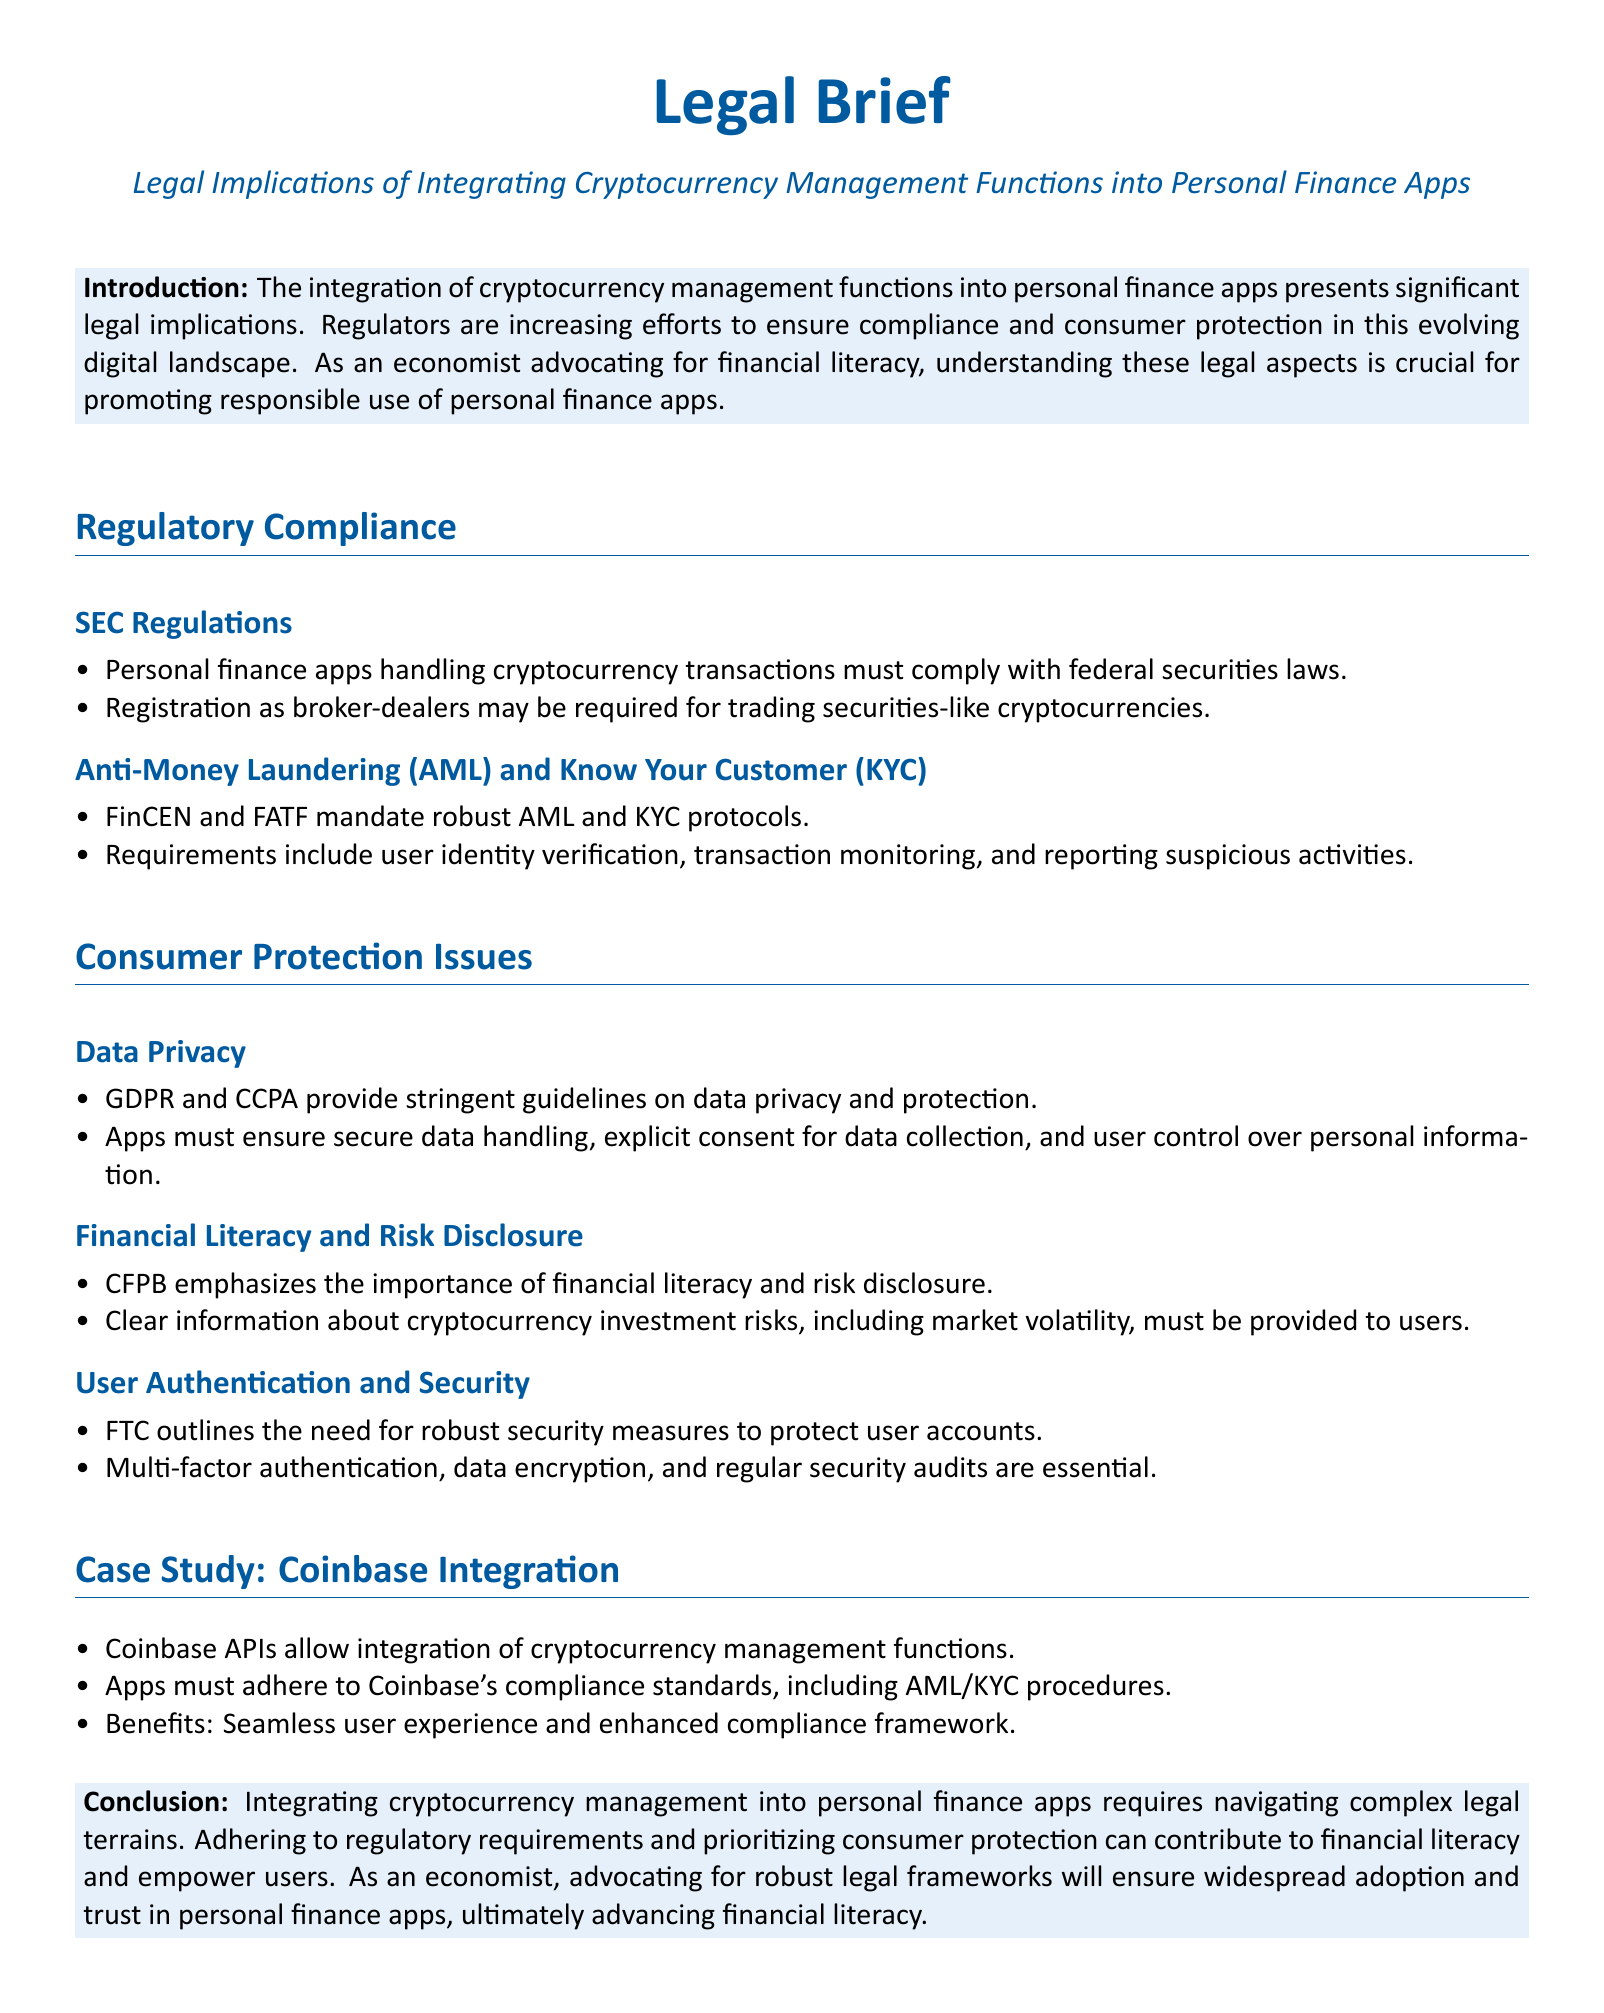What are the SEC regulations regarding personal finance apps? The SEC regulations state that personal finance apps handling cryptocurrency transactions must comply with federal securities laws.
Answer: Compliance with federal securities laws What is required for trading securities-like cryptocurrencies? It is stated that registration as broker-dealers may be required.
Answer: Registration as broker-dealers What protocols must be followed according to AML and KYC? The document specifies that FinCEN and FATF mandate robust AML and KYC protocols including user identity verification and transaction monitoring.
Answer: Robust AML and KYC protocols What guidelines do GDPR and CCPA provide? GDPR and CCPA provide stringent guidelines on data privacy and protection.
Answer: Data privacy and protection guidelines What does CFPB emphasize regarding financial literacy? The CFPB emphasizes the importance of financial literacy and risk disclosure.
Answer: Importance of financial literacy What security measures does the FTC outline? The FTC outlines the need for robust security measures, such as multi-factor authentication and data encryption.
Answer: Robust security measures Which APIs are mentioned for cryptocurrency integration? Coinbase APIs are mentioned for the integration of cryptocurrency management functions.
Answer: Coinbase APIs What specific compliance standards must be adhered to when using Coinbase? Apps must adhere to Coinbase's compliance standards, including AML/KYC procedures.
Answer: AML/KYC procedures What is the conclusion about integrating cryptocurrency management? The conclusion states that integrating cryptocurrency management into personal finance apps requires navigating complex legal terrains.
Answer: Navigating complex legal terrains 